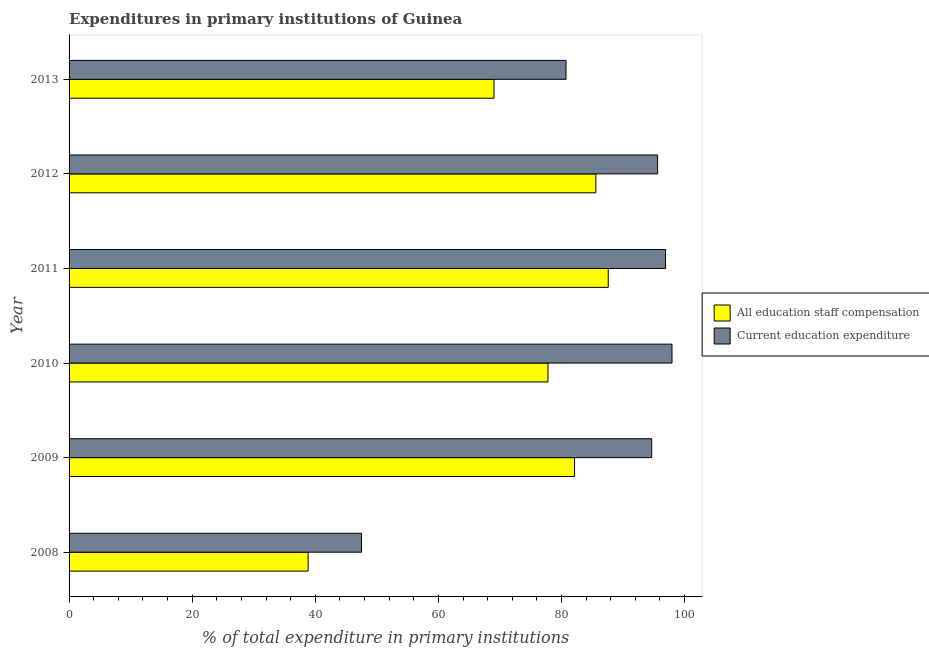How many different coloured bars are there?
Make the answer very short. 2. How many groups of bars are there?
Make the answer very short. 6. Are the number of bars on each tick of the Y-axis equal?
Keep it short and to the point. Yes. How many bars are there on the 3rd tick from the bottom?
Offer a terse response. 2. In how many cases, is the number of bars for a given year not equal to the number of legend labels?
Offer a terse response. 0. What is the expenditure in education in 2009?
Offer a terse response. 94.65. Across all years, what is the maximum expenditure in education?
Provide a succinct answer. 97.95. Across all years, what is the minimum expenditure in staff compensation?
Provide a short and direct response. 38.84. In which year was the expenditure in staff compensation minimum?
Keep it short and to the point. 2008. What is the total expenditure in staff compensation in the graph?
Keep it short and to the point. 440.97. What is the difference between the expenditure in education in 2010 and that in 2013?
Keep it short and to the point. 17.22. What is the difference between the expenditure in education in 2008 and the expenditure in staff compensation in 2009?
Keep it short and to the point. -34.6. What is the average expenditure in education per year?
Provide a short and direct response. 85.56. In the year 2008, what is the difference between the expenditure in staff compensation and expenditure in education?
Keep it short and to the point. -8.68. What is the ratio of the expenditure in staff compensation in 2008 to that in 2013?
Keep it short and to the point. 0.56. Is the difference between the expenditure in staff compensation in 2010 and 2011 greater than the difference between the expenditure in education in 2010 and 2011?
Give a very brief answer. No. What is the difference between the highest and the second highest expenditure in education?
Your answer should be very brief. 1.05. What is the difference between the highest and the lowest expenditure in staff compensation?
Your response must be concise. 48.75. Is the sum of the expenditure in staff compensation in 2008 and 2011 greater than the maximum expenditure in education across all years?
Make the answer very short. Yes. What does the 1st bar from the top in 2013 represents?
Your response must be concise. Current education expenditure. What does the 1st bar from the bottom in 2010 represents?
Offer a very short reply. All education staff compensation. What is the difference between two consecutive major ticks on the X-axis?
Give a very brief answer. 20. Are the values on the major ticks of X-axis written in scientific E-notation?
Give a very brief answer. No. Does the graph contain grids?
Offer a terse response. No. What is the title of the graph?
Provide a succinct answer. Expenditures in primary institutions of Guinea. What is the label or title of the X-axis?
Offer a terse response. % of total expenditure in primary institutions. What is the label or title of the Y-axis?
Provide a short and direct response. Year. What is the % of total expenditure in primary institutions of All education staff compensation in 2008?
Your answer should be very brief. 38.84. What is the % of total expenditure in primary institutions in Current education expenditure in 2008?
Ensure brevity in your answer.  47.51. What is the % of total expenditure in primary institutions of All education staff compensation in 2009?
Your response must be concise. 82.12. What is the % of total expenditure in primary institutions of Current education expenditure in 2009?
Your answer should be very brief. 94.65. What is the % of total expenditure in primary institutions in All education staff compensation in 2010?
Provide a succinct answer. 77.8. What is the % of total expenditure in primary institutions of Current education expenditure in 2010?
Give a very brief answer. 97.95. What is the % of total expenditure in primary institutions of All education staff compensation in 2011?
Provide a succinct answer. 87.59. What is the % of total expenditure in primary institutions in Current education expenditure in 2011?
Your answer should be very brief. 96.9. What is the % of total expenditure in primary institutions of All education staff compensation in 2012?
Your answer should be very brief. 85.58. What is the % of total expenditure in primary institutions in Current education expenditure in 2012?
Keep it short and to the point. 95.61. What is the % of total expenditure in primary institutions in All education staff compensation in 2013?
Offer a terse response. 69.03. What is the % of total expenditure in primary institutions in Current education expenditure in 2013?
Keep it short and to the point. 80.73. Across all years, what is the maximum % of total expenditure in primary institutions of All education staff compensation?
Keep it short and to the point. 87.59. Across all years, what is the maximum % of total expenditure in primary institutions of Current education expenditure?
Your answer should be compact. 97.95. Across all years, what is the minimum % of total expenditure in primary institutions of All education staff compensation?
Give a very brief answer. 38.84. Across all years, what is the minimum % of total expenditure in primary institutions of Current education expenditure?
Offer a terse response. 47.51. What is the total % of total expenditure in primary institutions in All education staff compensation in the graph?
Offer a very short reply. 440.97. What is the total % of total expenditure in primary institutions of Current education expenditure in the graph?
Provide a succinct answer. 513.37. What is the difference between the % of total expenditure in primary institutions of All education staff compensation in 2008 and that in 2009?
Make the answer very short. -43.28. What is the difference between the % of total expenditure in primary institutions of Current education expenditure in 2008 and that in 2009?
Keep it short and to the point. -47.14. What is the difference between the % of total expenditure in primary institutions of All education staff compensation in 2008 and that in 2010?
Your answer should be compact. -38.97. What is the difference between the % of total expenditure in primary institutions in Current education expenditure in 2008 and that in 2010?
Your answer should be very brief. -50.44. What is the difference between the % of total expenditure in primary institutions of All education staff compensation in 2008 and that in 2011?
Make the answer very short. -48.75. What is the difference between the % of total expenditure in primary institutions of Current education expenditure in 2008 and that in 2011?
Offer a terse response. -49.39. What is the difference between the % of total expenditure in primary institutions in All education staff compensation in 2008 and that in 2012?
Provide a succinct answer. -46.74. What is the difference between the % of total expenditure in primary institutions of Current education expenditure in 2008 and that in 2012?
Your answer should be very brief. -48.1. What is the difference between the % of total expenditure in primary institutions of All education staff compensation in 2008 and that in 2013?
Make the answer very short. -30.2. What is the difference between the % of total expenditure in primary institutions in Current education expenditure in 2008 and that in 2013?
Offer a very short reply. -33.22. What is the difference between the % of total expenditure in primary institutions in All education staff compensation in 2009 and that in 2010?
Provide a short and direct response. 4.31. What is the difference between the % of total expenditure in primary institutions in Current education expenditure in 2009 and that in 2010?
Make the answer very short. -3.3. What is the difference between the % of total expenditure in primary institutions in All education staff compensation in 2009 and that in 2011?
Provide a short and direct response. -5.47. What is the difference between the % of total expenditure in primary institutions in Current education expenditure in 2009 and that in 2011?
Your response must be concise. -2.25. What is the difference between the % of total expenditure in primary institutions in All education staff compensation in 2009 and that in 2012?
Your answer should be very brief. -3.46. What is the difference between the % of total expenditure in primary institutions of Current education expenditure in 2009 and that in 2012?
Ensure brevity in your answer.  -0.96. What is the difference between the % of total expenditure in primary institutions in All education staff compensation in 2009 and that in 2013?
Your answer should be very brief. 13.08. What is the difference between the % of total expenditure in primary institutions in Current education expenditure in 2009 and that in 2013?
Your response must be concise. 13.92. What is the difference between the % of total expenditure in primary institutions of All education staff compensation in 2010 and that in 2011?
Offer a terse response. -9.79. What is the difference between the % of total expenditure in primary institutions in Current education expenditure in 2010 and that in 2011?
Make the answer very short. 1.05. What is the difference between the % of total expenditure in primary institutions of All education staff compensation in 2010 and that in 2012?
Offer a very short reply. -7.77. What is the difference between the % of total expenditure in primary institutions of Current education expenditure in 2010 and that in 2012?
Make the answer very short. 2.34. What is the difference between the % of total expenditure in primary institutions of All education staff compensation in 2010 and that in 2013?
Keep it short and to the point. 8.77. What is the difference between the % of total expenditure in primary institutions of Current education expenditure in 2010 and that in 2013?
Keep it short and to the point. 17.22. What is the difference between the % of total expenditure in primary institutions in All education staff compensation in 2011 and that in 2012?
Ensure brevity in your answer.  2.01. What is the difference between the % of total expenditure in primary institutions of Current education expenditure in 2011 and that in 2012?
Make the answer very short. 1.29. What is the difference between the % of total expenditure in primary institutions in All education staff compensation in 2011 and that in 2013?
Your response must be concise. 18.56. What is the difference between the % of total expenditure in primary institutions in Current education expenditure in 2011 and that in 2013?
Your answer should be compact. 16.17. What is the difference between the % of total expenditure in primary institutions in All education staff compensation in 2012 and that in 2013?
Make the answer very short. 16.54. What is the difference between the % of total expenditure in primary institutions in Current education expenditure in 2012 and that in 2013?
Provide a short and direct response. 14.88. What is the difference between the % of total expenditure in primary institutions of All education staff compensation in 2008 and the % of total expenditure in primary institutions of Current education expenditure in 2009?
Your answer should be compact. -55.81. What is the difference between the % of total expenditure in primary institutions in All education staff compensation in 2008 and the % of total expenditure in primary institutions in Current education expenditure in 2010?
Keep it short and to the point. -59.11. What is the difference between the % of total expenditure in primary institutions of All education staff compensation in 2008 and the % of total expenditure in primary institutions of Current education expenditure in 2011?
Ensure brevity in your answer.  -58.06. What is the difference between the % of total expenditure in primary institutions in All education staff compensation in 2008 and the % of total expenditure in primary institutions in Current education expenditure in 2012?
Make the answer very short. -56.77. What is the difference between the % of total expenditure in primary institutions of All education staff compensation in 2008 and the % of total expenditure in primary institutions of Current education expenditure in 2013?
Your answer should be very brief. -41.89. What is the difference between the % of total expenditure in primary institutions in All education staff compensation in 2009 and the % of total expenditure in primary institutions in Current education expenditure in 2010?
Offer a terse response. -15.83. What is the difference between the % of total expenditure in primary institutions in All education staff compensation in 2009 and the % of total expenditure in primary institutions in Current education expenditure in 2011?
Keep it short and to the point. -14.78. What is the difference between the % of total expenditure in primary institutions in All education staff compensation in 2009 and the % of total expenditure in primary institutions in Current education expenditure in 2012?
Make the answer very short. -13.49. What is the difference between the % of total expenditure in primary institutions in All education staff compensation in 2009 and the % of total expenditure in primary institutions in Current education expenditure in 2013?
Your answer should be compact. 1.38. What is the difference between the % of total expenditure in primary institutions of All education staff compensation in 2010 and the % of total expenditure in primary institutions of Current education expenditure in 2011?
Offer a very short reply. -19.1. What is the difference between the % of total expenditure in primary institutions of All education staff compensation in 2010 and the % of total expenditure in primary institutions of Current education expenditure in 2012?
Make the answer very short. -17.81. What is the difference between the % of total expenditure in primary institutions of All education staff compensation in 2010 and the % of total expenditure in primary institutions of Current education expenditure in 2013?
Provide a short and direct response. -2.93. What is the difference between the % of total expenditure in primary institutions of All education staff compensation in 2011 and the % of total expenditure in primary institutions of Current education expenditure in 2012?
Give a very brief answer. -8.02. What is the difference between the % of total expenditure in primary institutions in All education staff compensation in 2011 and the % of total expenditure in primary institutions in Current education expenditure in 2013?
Your answer should be compact. 6.86. What is the difference between the % of total expenditure in primary institutions in All education staff compensation in 2012 and the % of total expenditure in primary institutions in Current education expenditure in 2013?
Offer a terse response. 4.84. What is the average % of total expenditure in primary institutions in All education staff compensation per year?
Make the answer very short. 73.49. What is the average % of total expenditure in primary institutions in Current education expenditure per year?
Your answer should be compact. 85.56. In the year 2008, what is the difference between the % of total expenditure in primary institutions in All education staff compensation and % of total expenditure in primary institutions in Current education expenditure?
Your answer should be compact. -8.67. In the year 2009, what is the difference between the % of total expenditure in primary institutions in All education staff compensation and % of total expenditure in primary institutions in Current education expenditure?
Ensure brevity in your answer.  -12.53. In the year 2010, what is the difference between the % of total expenditure in primary institutions in All education staff compensation and % of total expenditure in primary institutions in Current education expenditure?
Provide a short and direct response. -20.15. In the year 2011, what is the difference between the % of total expenditure in primary institutions of All education staff compensation and % of total expenditure in primary institutions of Current education expenditure?
Your answer should be very brief. -9.31. In the year 2012, what is the difference between the % of total expenditure in primary institutions in All education staff compensation and % of total expenditure in primary institutions in Current education expenditure?
Your answer should be compact. -10.04. In the year 2013, what is the difference between the % of total expenditure in primary institutions in All education staff compensation and % of total expenditure in primary institutions in Current education expenditure?
Offer a terse response. -11.7. What is the ratio of the % of total expenditure in primary institutions in All education staff compensation in 2008 to that in 2009?
Your answer should be very brief. 0.47. What is the ratio of the % of total expenditure in primary institutions of Current education expenditure in 2008 to that in 2009?
Make the answer very short. 0.5. What is the ratio of the % of total expenditure in primary institutions of All education staff compensation in 2008 to that in 2010?
Your response must be concise. 0.5. What is the ratio of the % of total expenditure in primary institutions in Current education expenditure in 2008 to that in 2010?
Your response must be concise. 0.49. What is the ratio of the % of total expenditure in primary institutions in All education staff compensation in 2008 to that in 2011?
Your answer should be compact. 0.44. What is the ratio of the % of total expenditure in primary institutions of Current education expenditure in 2008 to that in 2011?
Your answer should be very brief. 0.49. What is the ratio of the % of total expenditure in primary institutions of All education staff compensation in 2008 to that in 2012?
Your response must be concise. 0.45. What is the ratio of the % of total expenditure in primary institutions in Current education expenditure in 2008 to that in 2012?
Keep it short and to the point. 0.5. What is the ratio of the % of total expenditure in primary institutions in All education staff compensation in 2008 to that in 2013?
Offer a terse response. 0.56. What is the ratio of the % of total expenditure in primary institutions in Current education expenditure in 2008 to that in 2013?
Provide a succinct answer. 0.59. What is the ratio of the % of total expenditure in primary institutions in All education staff compensation in 2009 to that in 2010?
Ensure brevity in your answer.  1.06. What is the ratio of the % of total expenditure in primary institutions in Current education expenditure in 2009 to that in 2010?
Offer a very short reply. 0.97. What is the ratio of the % of total expenditure in primary institutions of Current education expenditure in 2009 to that in 2011?
Your answer should be compact. 0.98. What is the ratio of the % of total expenditure in primary institutions in All education staff compensation in 2009 to that in 2012?
Keep it short and to the point. 0.96. What is the ratio of the % of total expenditure in primary institutions in All education staff compensation in 2009 to that in 2013?
Keep it short and to the point. 1.19. What is the ratio of the % of total expenditure in primary institutions of Current education expenditure in 2009 to that in 2013?
Provide a short and direct response. 1.17. What is the ratio of the % of total expenditure in primary institutions of All education staff compensation in 2010 to that in 2011?
Provide a succinct answer. 0.89. What is the ratio of the % of total expenditure in primary institutions of Current education expenditure in 2010 to that in 2011?
Make the answer very short. 1.01. What is the ratio of the % of total expenditure in primary institutions in All education staff compensation in 2010 to that in 2012?
Keep it short and to the point. 0.91. What is the ratio of the % of total expenditure in primary institutions in Current education expenditure in 2010 to that in 2012?
Offer a terse response. 1.02. What is the ratio of the % of total expenditure in primary institutions in All education staff compensation in 2010 to that in 2013?
Your answer should be compact. 1.13. What is the ratio of the % of total expenditure in primary institutions of Current education expenditure in 2010 to that in 2013?
Ensure brevity in your answer.  1.21. What is the ratio of the % of total expenditure in primary institutions in All education staff compensation in 2011 to that in 2012?
Ensure brevity in your answer.  1.02. What is the ratio of the % of total expenditure in primary institutions of Current education expenditure in 2011 to that in 2012?
Your response must be concise. 1.01. What is the ratio of the % of total expenditure in primary institutions in All education staff compensation in 2011 to that in 2013?
Provide a succinct answer. 1.27. What is the ratio of the % of total expenditure in primary institutions in Current education expenditure in 2011 to that in 2013?
Provide a succinct answer. 1.2. What is the ratio of the % of total expenditure in primary institutions in All education staff compensation in 2012 to that in 2013?
Provide a short and direct response. 1.24. What is the ratio of the % of total expenditure in primary institutions in Current education expenditure in 2012 to that in 2013?
Provide a short and direct response. 1.18. What is the difference between the highest and the second highest % of total expenditure in primary institutions in All education staff compensation?
Keep it short and to the point. 2.01. What is the difference between the highest and the second highest % of total expenditure in primary institutions of Current education expenditure?
Keep it short and to the point. 1.05. What is the difference between the highest and the lowest % of total expenditure in primary institutions in All education staff compensation?
Provide a short and direct response. 48.75. What is the difference between the highest and the lowest % of total expenditure in primary institutions in Current education expenditure?
Provide a succinct answer. 50.44. 